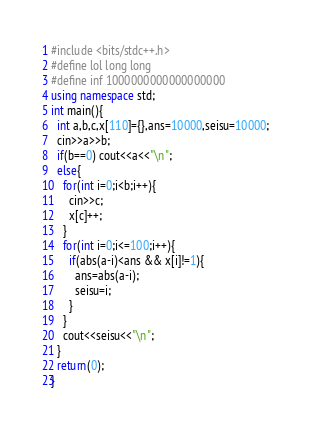<code> <loc_0><loc_0><loc_500><loc_500><_C++_>#include <bits/stdc++.h>
#define lol long long
#define inf 1000000000000000000
using namespace std;
int main(){
  int a,b,c,x[110]={},ans=10000,seisu=10000;
  cin>>a>>b;
  if(b==0) cout<<a<<"\n";
  else{
    for(int i=0;i<b;i++){
      cin>>c;
      x[c]++;
    } 
    for(int i=0;i<=100;i++){
      if(abs(a-i)<ans && x[i]!=1){
        ans=abs(a-i);
        seisu=i;
      }
    }
    cout<<seisu<<"\n";
  }
  return(0);
}</code> 